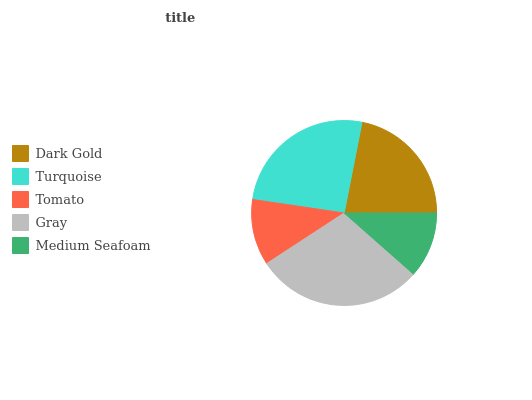Is Medium Seafoam the minimum?
Answer yes or no. Yes. Is Gray the maximum?
Answer yes or no. Yes. Is Turquoise the minimum?
Answer yes or no. No. Is Turquoise the maximum?
Answer yes or no. No. Is Turquoise greater than Dark Gold?
Answer yes or no. Yes. Is Dark Gold less than Turquoise?
Answer yes or no. Yes. Is Dark Gold greater than Turquoise?
Answer yes or no. No. Is Turquoise less than Dark Gold?
Answer yes or no. No. Is Dark Gold the high median?
Answer yes or no. Yes. Is Dark Gold the low median?
Answer yes or no. Yes. Is Tomato the high median?
Answer yes or no. No. Is Turquoise the low median?
Answer yes or no. No. 